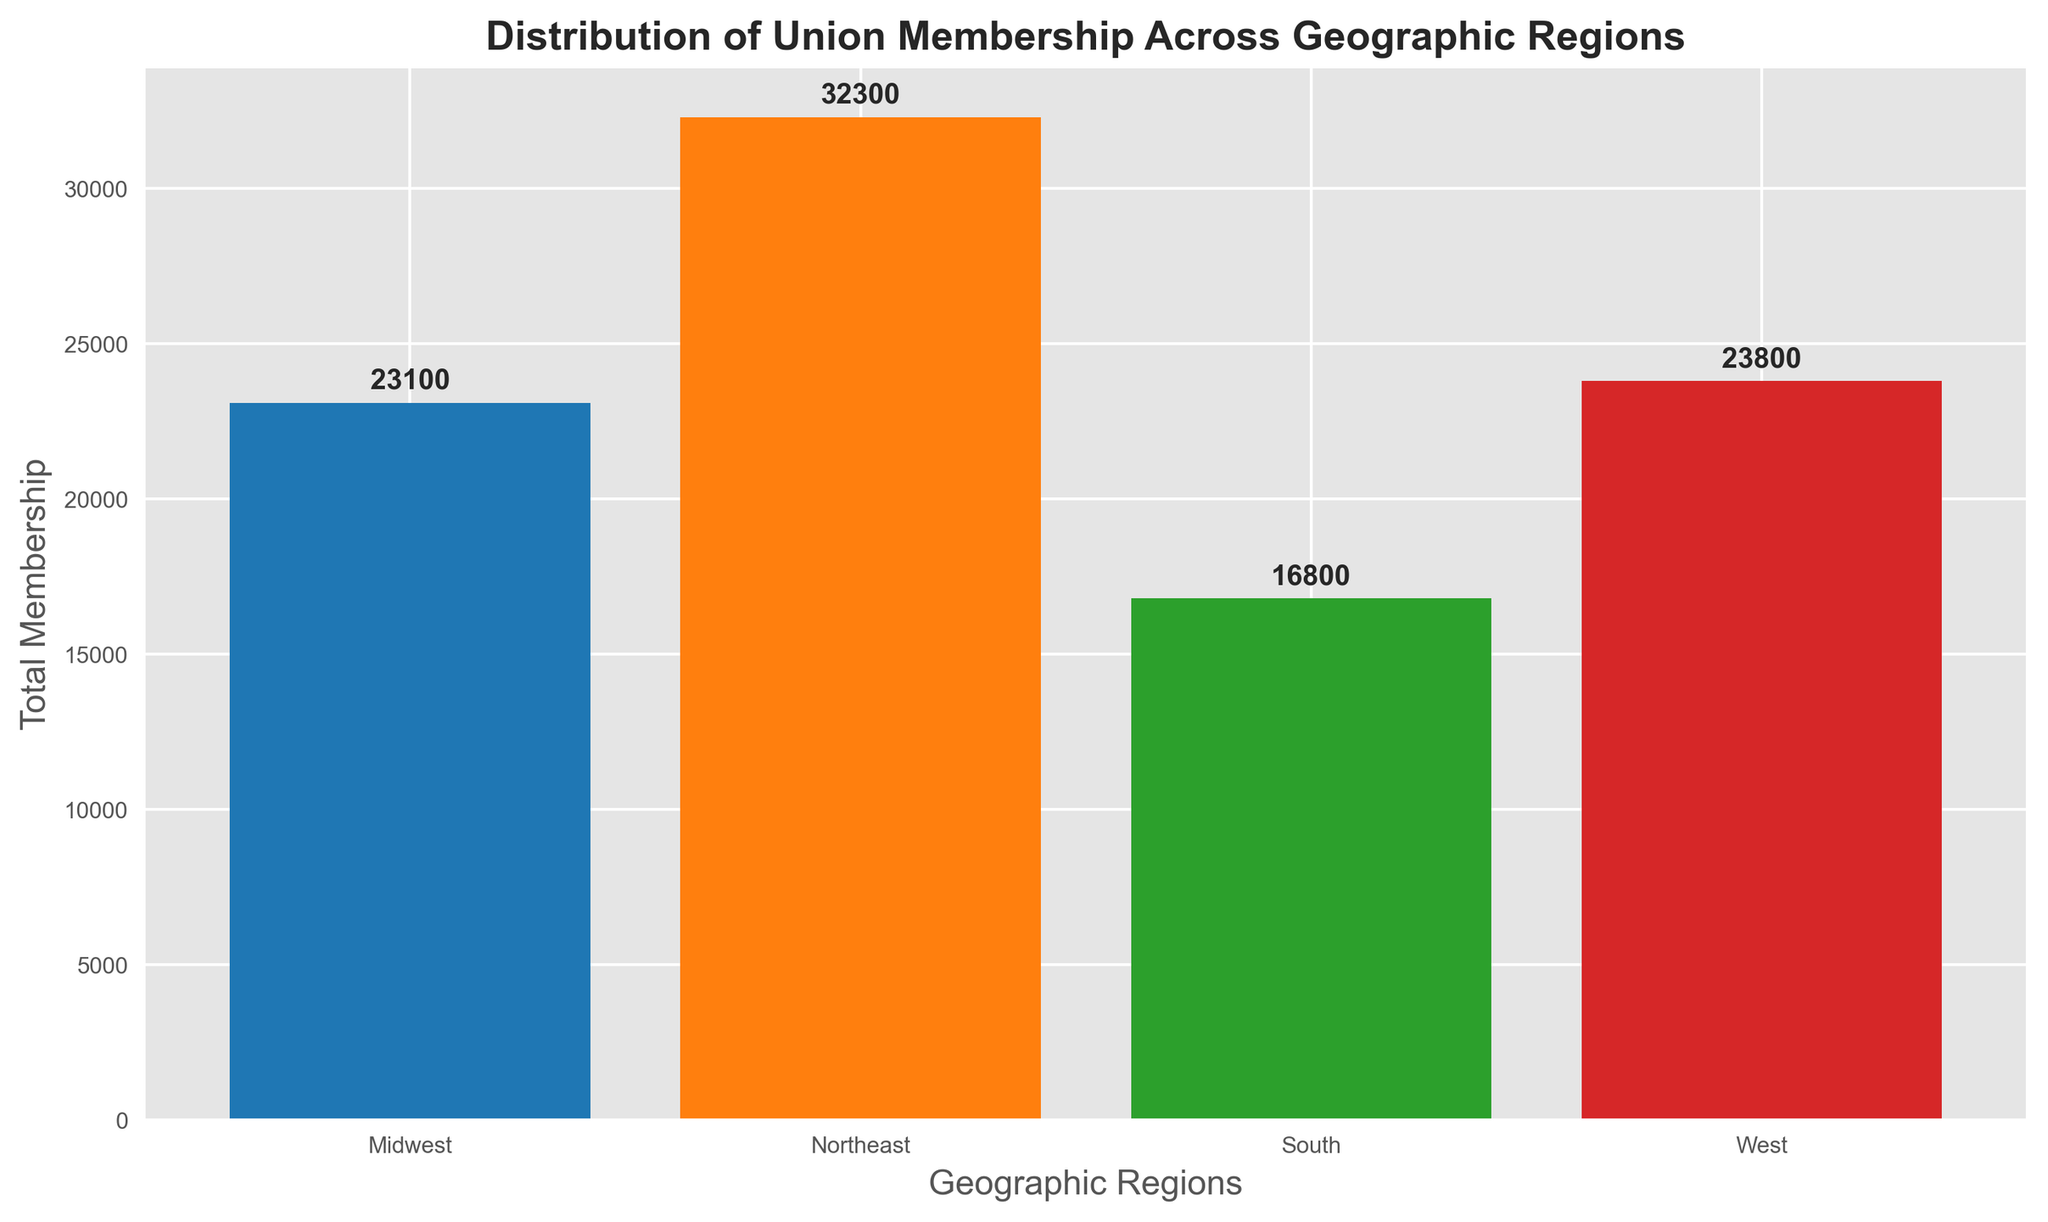How many more members does the Northeast region have compared to the South region? To find the difference, subtract the total membership of the South from that of the Northeast. According to the plot, the Northeast has 31,200 members, and the South has 17,000 members. The difference is 31,200 - 17,000 = 14,200 members.
Answer: 14,200 Which region has the second highest total union membership? Refer to the heights of the bars in the plot. The Northeast region has the highest membership. The West region has the second highest with 20,800 members.
Answer: West Is the total membership of the Midwest region greater than that of the South region? Compare the heights of the bars representing the Midwest and South regions. The Midwest has 20,100 members, while the South has 17,000. Since 20,100 > 17,000, the Midwest's membership is greater.
Answer: Yes What is the average total membership across all regions? Sum the total memberships of all regions and divide by the number of regions. The totals are: Northeast (31,200), Midwest (20,100), South (17,000), and West (20,800). The average is (31,200 + 20,100 + 17,000 + 20,800) / 4 = 89,100 / 4 = 22,275.
Answer: 22,275 Which region shows the lowest total membership? Identify the bar with the shortest height. The South region, with a total membership of 17,000, has the lowest membership.
Answer: South What is the total membership of the West and Midwest regions combined? Add the memberships of the West and Midwest regions. According to the plot, the West has 20,800 members and the Midwest has 20,100. The combined membership is 20,800 + 20,100 = 40,900.
Answer: 40,900 Does the Northeast region's membership exceed the combined membership of the South and West regions? Compare the Northeast's membership with the sum of the South and West regions. The Northeast has 31,200 members. The South and West combined have 17,000 + 20,800 = 37,800 members. Since 31,200 < 37,800, the Northeast does not exceed the combined membership.
Answer: No What is the difference between the total membership of the West and the Northeast regions? Subtract the total membership of the West from that of the Northeast. The Northeast has 31,200 members, and the West has 20,800 members. The difference is 31,200 - 20,800 = 10,400 members.
Answer: 10,400 Which region has the highest membership, and what is that number? The bar with the greatest height corresponds to the Northeast region. The membership total for the Northeast is 31,200 members.
Answer: Northeast, 31,200 What is the ratio of the Northeast region's total membership to the Midwest region's total membership? Divide the total membership of the Northeast by that of the Midwest. The Northeast has 31,200 members, and the Midwest has 20,100 members. The ratio is 31,200 / 20,100 ≈ 1.55.
Answer: 1.55 